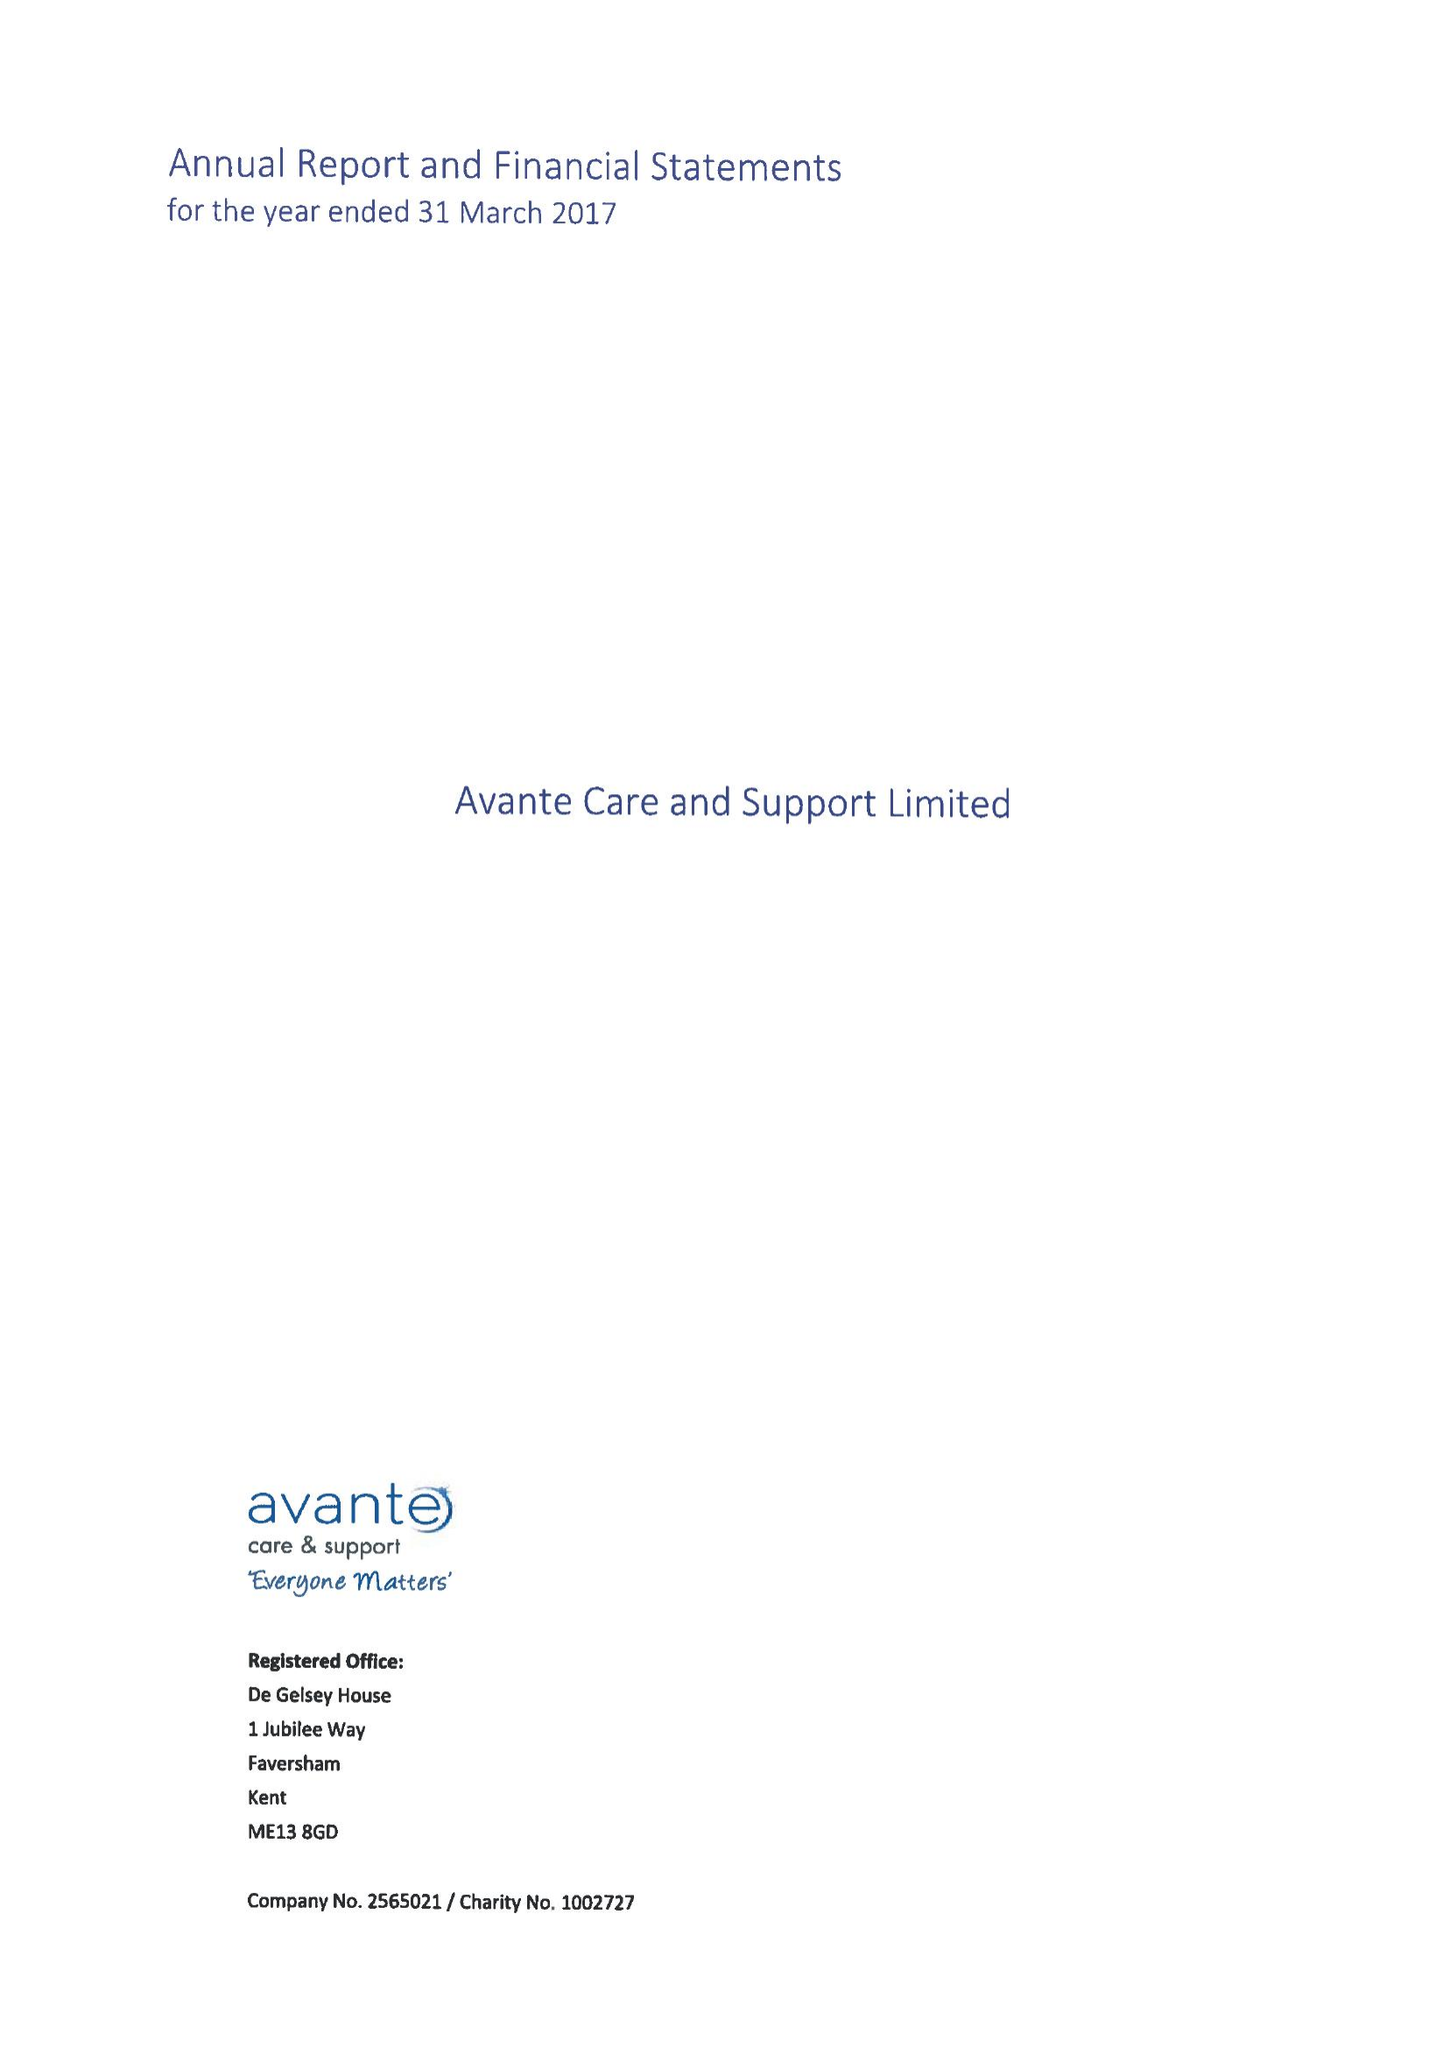What is the value for the report_date?
Answer the question using a single word or phrase. 2017-03-31 